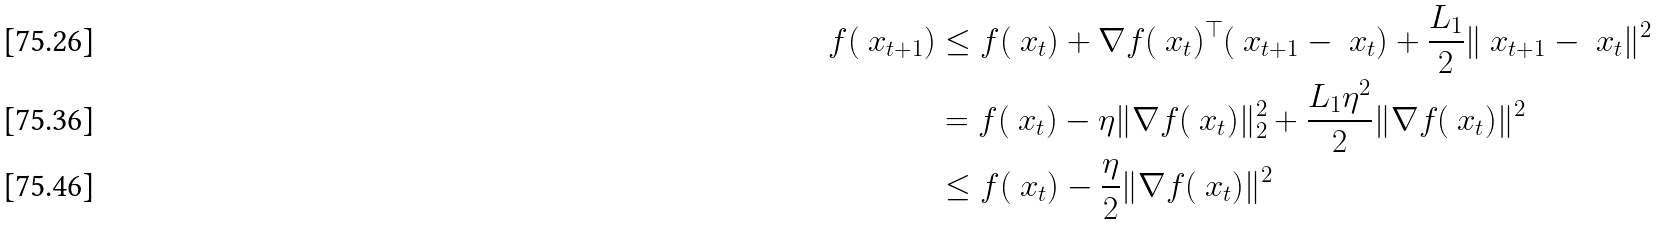<formula> <loc_0><loc_0><loc_500><loc_500>f ( \ x _ { t + 1 } ) & \leq f ( \ x _ { t } ) + \nabla f ( \ x _ { t } ) ^ { \top } ( \ x _ { t + 1 } - \ x _ { t } ) + \frac { L _ { 1 } } { 2 } \| \ x _ { t + 1 } - \ x _ { t } \| ^ { 2 } \\ & = f ( \ x _ { t } ) - \eta \| \nabla f ( \ x _ { t } ) \| _ { 2 } ^ { 2 } + \frac { L _ { 1 } \eta ^ { 2 } } { 2 } \| \nabla f ( \ x _ { t } ) \| ^ { 2 } \\ & \leq f ( \ x _ { t } ) - \frac { \eta } { 2 } \| \nabla f ( \ x _ { t } ) \| ^ { 2 }</formula> 